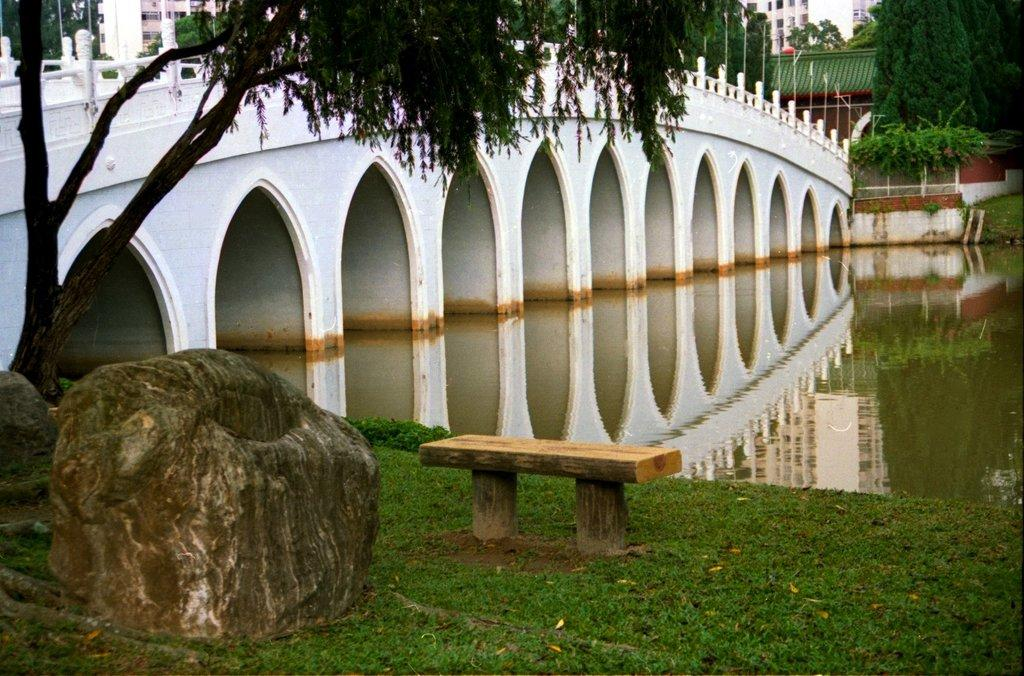What is located in the foreground of the image? There is a wooden bench and grassland in the foreground of the image. What other objects can be seen in the foreground? There are stones in the foreground of the image. What is visible in the background of the image? There are trees, buildings, arches, a bridge, and water visible in the background of the image. What type of toothpaste is being used to clean the wooden bench in the image? There is no toothpaste present in the image, and the wooden bench is not being cleaned. How does the death of the trees in the background of the image affect the overall composition? There is no indication of any trees dying in the image, and the presence of trees in the background contributes to the overall composition. 